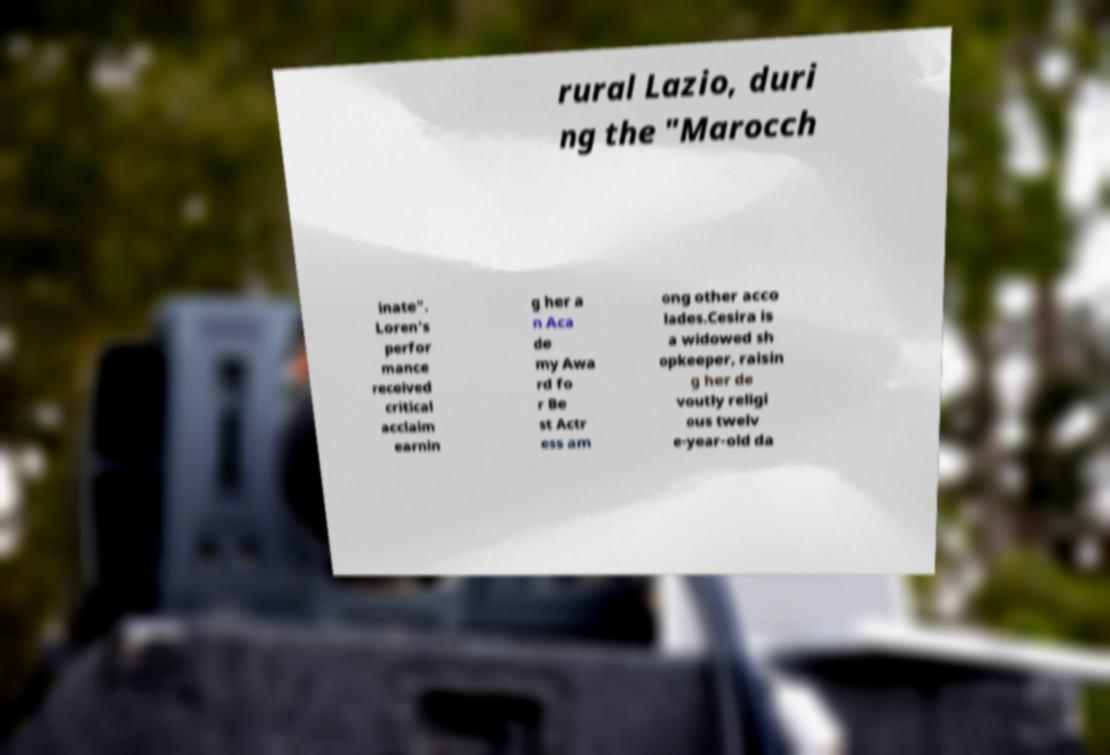Can you read and provide the text displayed in the image?This photo seems to have some interesting text. Can you extract and type it out for me? rural Lazio, duri ng the "Marocch inate". Loren's perfor mance received critical acclaim earnin g her a n Aca de my Awa rd fo r Be st Actr ess am ong other acco lades.Cesira is a widowed sh opkeeper, raisin g her de voutly religi ous twelv e-year-old da 